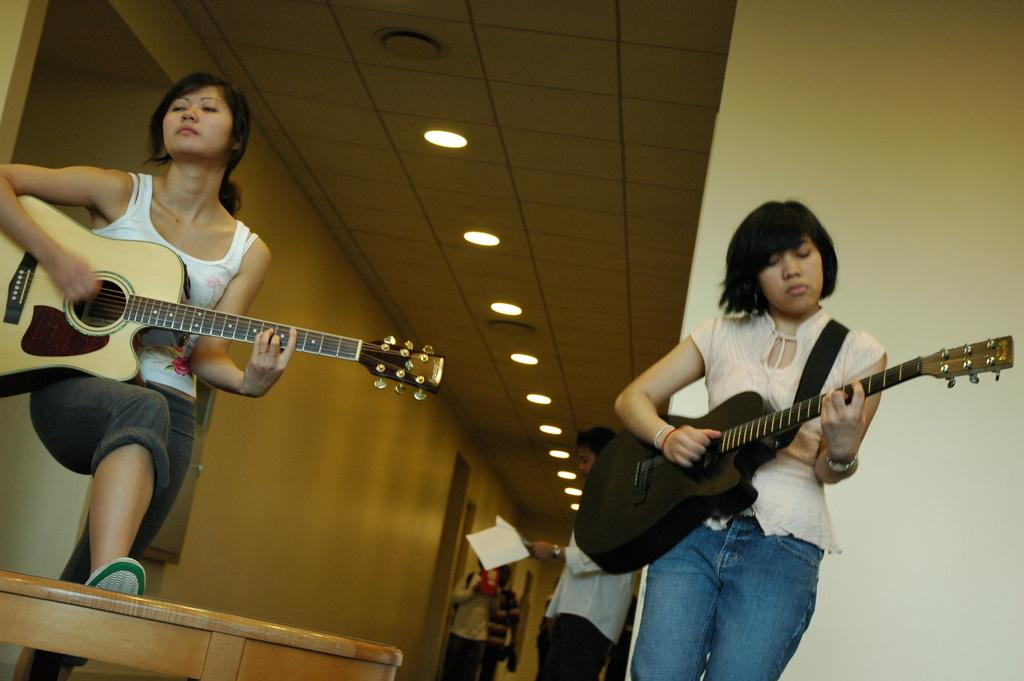How many women are in the image? There are two women in the image. What are the women doing in the image? The women are standing and playing guitar. Can you describe the background of the image? There are people in the background of the image, and there are lights attached to the roof. What type of slave is depicted in the image? There is no slave depicted in the image; it features two women playing guitar. Can you tell me how many rifles are visible in the image? There are no rifles present in the image. 